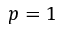Convert formula to latex. <formula><loc_0><loc_0><loc_500><loc_500>p = 1</formula> 